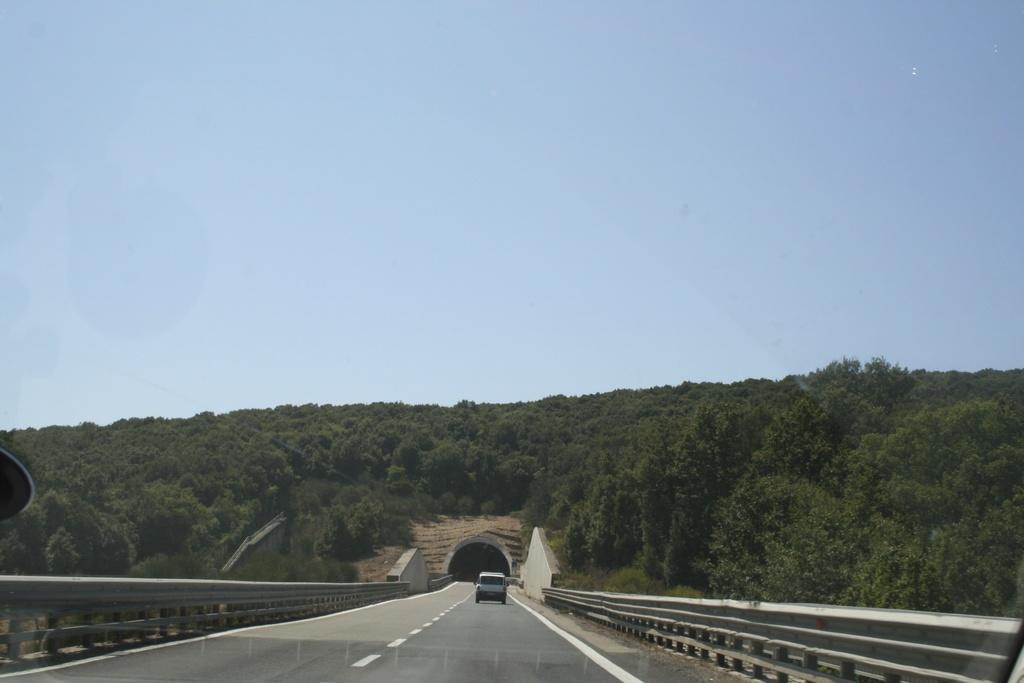What is the main feature of the image? There is a road in the image. What is happening on the road? A car is moving on the road. What can be seen in the background of the image? There are trees in the background of the image. What is present on both sides of the road? There is a fence on both sides of the road. What type of feather can be seen floating in the air in the image? There is no feather present in the image; it only features a road, a car, trees, and fences. 